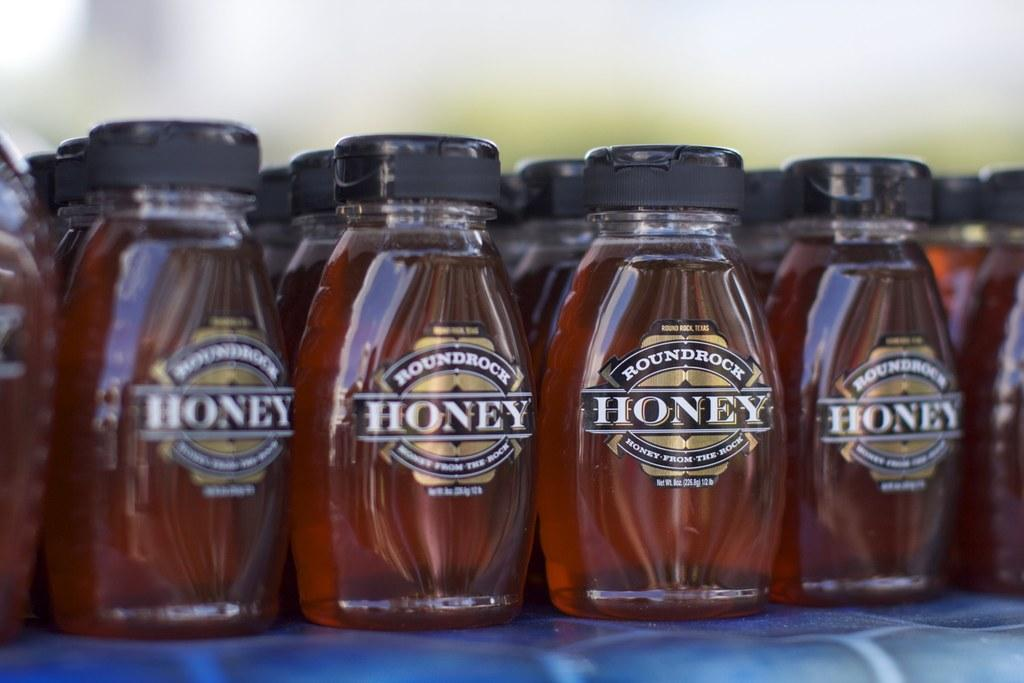<image>
Share a concise interpretation of the image provided. Honey bottles are lined and displayed on a shelf 